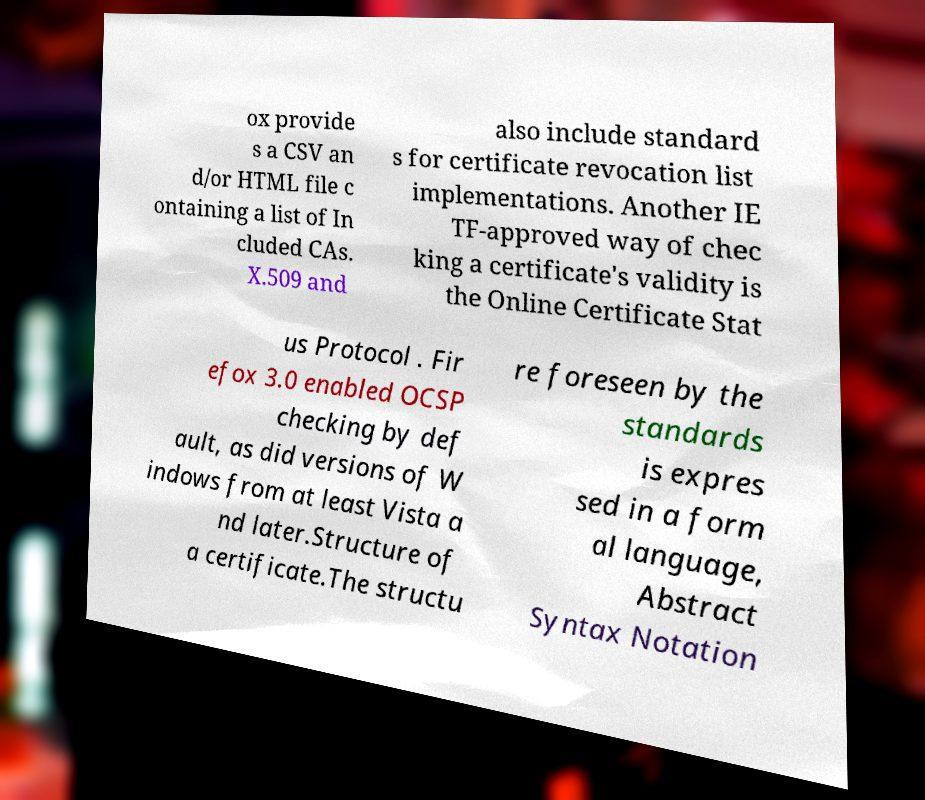Please read and relay the text visible in this image. What does it say? ox provide s a CSV an d/or HTML file c ontaining a list of In cluded CAs. X.509 and also include standard s for certificate revocation list implementations. Another IE TF-approved way of chec king a certificate's validity is the Online Certificate Stat us Protocol . Fir efox 3.0 enabled OCSP checking by def ault, as did versions of W indows from at least Vista a nd later.Structure of a certificate.The structu re foreseen by the standards is expres sed in a form al language, Abstract Syntax Notation 